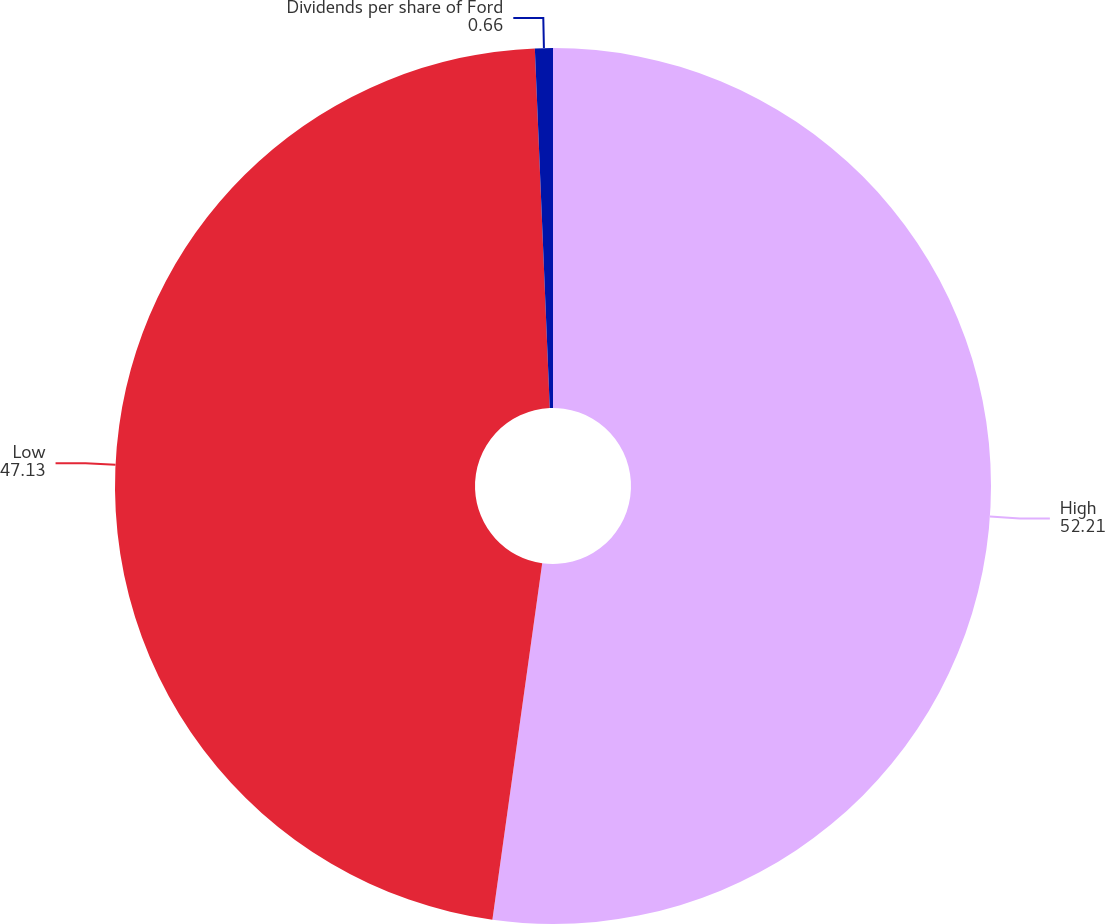<chart> <loc_0><loc_0><loc_500><loc_500><pie_chart><fcel>High<fcel>Low<fcel>Dividends per share of Ford<nl><fcel>52.21%<fcel>47.13%<fcel>0.66%<nl></chart> 